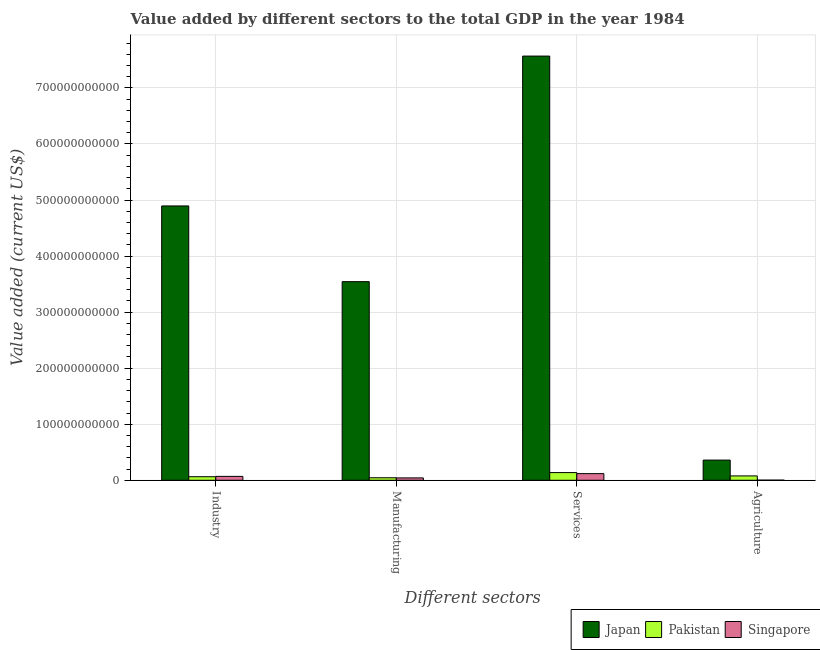Are the number of bars on each tick of the X-axis equal?
Your response must be concise. Yes. How many bars are there on the 1st tick from the right?
Make the answer very short. 3. What is the label of the 4th group of bars from the left?
Ensure brevity in your answer.  Agriculture. What is the value added by industrial sector in Pakistan?
Provide a short and direct response. 6.31e+09. Across all countries, what is the maximum value added by industrial sector?
Offer a very short reply. 4.89e+11. Across all countries, what is the minimum value added by industrial sector?
Ensure brevity in your answer.  6.31e+09. In which country was the value added by services sector minimum?
Provide a short and direct response. Singapore. What is the total value added by services sector in the graph?
Your answer should be very brief. 7.82e+11. What is the difference between the value added by services sector in Japan and that in Pakistan?
Provide a succinct answer. 7.43e+11. What is the difference between the value added by industrial sector in Pakistan and the value added by manufacturing sector in Japan?
Keep it short and to the point. -3.48e+11. What is the average value added by industrial sector per country?
Your response must be concise. 1.68e+11. What is the difference between the value added by manufacturing sector and value added by services sector in Japan?
Give a very brief answer. -4.02e+11. What is the ratio of the value added by agricultural sector in Singapore to that in Japan?
Make the answer very short. 0.01. Is the value added by manufacturing sector in Japan less than that in Singapore?
Your answer should be compact. No. What is the difference between the highest and the second highest value added by industrial sector?
Provide a succinct answer. 4.82e+11. What is the difference between the highest and the lowest value added by agricultural sector?
Offer a terse response. 3.58e+1. In how many countries, is the value added by manufacturing sector greater than the average value added by manufacturing sector taken over all countries?
Offer a very short reply. 1. Is it the case that in every country, the sum of the value added by services sector and value added by manufacturing sector is greater than the sum of value added by agricultural sector and value added by industrial sector?
Offer a terse response. No. What does the 3rd bar from the right in Industry represents?
Offer a terse response. Japan. Is it the case that in every country, the sum of the value added by industrial sector and value added by manufacturing sector is greater than the value added by services sector?
Keep it short and to the point. No. How many bars are there?
Your answer should be compact. 12. Are all the bars in the graph horizontal?
Offer a terse response. No. What is the difference between two consecutive major ticks on the Y-axis?
Ensure brevity in your answer.  1.00e+11. Does the graph contain grids?
Make the answer very short. Yes. How many legend labels are there?
Your response must be concise. 3. How are the legend labels stacked?
Your answer should be very brief. Horizontal. What is the title of the graph?
Your response must be concise. Value added by different sectors to the total GDP in the year 1984. Does "Lithuania" appear as one of the legend labels in the graph?
Your answer should be compact. No. What is the label or title of the X-axis?
Provide a succinct answer. Different sectors. What is the label or title of the Y-axis?
Provide a short and direct response. Value added (current US$). What is the Value added (current US$) of Japan in Industry?
Offer a very short reply. 4.89e+11. What is the Value added (current US$) of Pakistan in Industry?
Make the answer very short. 6.31e+09. What is the Value added (current US$) in Singapore in Industry?
Your answer should be compact. 6.94e+09. What is the Value added (current US$) in Japan in Manufacturing?
Keep it short and to the point. 3.54e+11. What is the Value added (current US$) in Pakistan in Manufacturing?
Make the answer very short. 4.48e+09. What is the Value added (current US$) of Singapore in Manufacturing?
Your response must be concise. 4.22e+09. What is the Value added (current US$) in Japan in Services?
Give a very brief answer. 7.57e+11. What is the Value added (current US$) in Pakistan in Services?
Your answer should be compact. 1.37e+1. What is the Value added (current US$) of Singapore in Services?
Make the answer very short. 1.18e+1. What is the Value added (current US$) of Japan in Agriculture?
Make the answer very short. 3.60e+1. What is the Value added (current US$) in Pakistan in Agriculture?
Give a very brief answer. 7.75e+09. What is the Value added (current US$) of Singapore in Agriculture?
Ensure brevity in your answer.  2.11e+08. Across all Different sectors, what is the maximum Value added (current US$) in Japan?
Provide a succinct answer. 7.57e+11. Across all Different sectors, what is the maximum Value added (current US$) in Pakistan?
Your answer should be compact. 1.37e+1. Across all Different sectors, what is the maximum Value added (current US$) of Singapore?
Your answer should be very brief. 1.18e+1. Across all Different sectors, what is the minimum Value added (current US$) in Japan?
Make the answer very short. 3.60e+1. Across all Different sectors, what is the minimum Value added (current US$) in Pakistan?
Ensure brevity in your answer.  4.48e+09. Across all Different sectors, what is the minimum Value added (current US$) of Singapore?
Keep it short and to the point. 2.11e+08. What is the total Value added (current US$) in Japan in the graph?
Make the answer very short. 1.64e+12. What is the total Value added (current US$) of Pakistan in the graph?
Make the answer very short. 3.23e+1. What is the total Value added (current US$) in Singapore in the graph?
Ensure brevity in your answer.  2.32e+1. What is the difference between the Value added (current US$) in Japan in Industry and that in Manufacturing?
Your answer should be very brief. 1.35e+11. What is the difference between the Value added (current US$) in Pakistan in Industry and that in Manufacturing?
Your answer should be very brief. 1.83e+09. What is the difference between the Value added (current US$) of Singapore in Industry and that in Manufacturing?
Your response must be concise. 2.72e+09. What is the difference between the Value added (current US$) of Japan in Industry and that in Services?
Make the answer very short. -2.67e+11. What is the difference between the Value added (current US$) in Pakistan in Industry and that in Services?
Give a very brief answer. -7.41e+09. What is the difference between the Value added (current US$) of Singapore in Industry and that in Services?
Your response must be concise. -4.90e+09. What is the difference between the Value added (current US$) in Japan in Industry and that in Agriculture?
Ensure brevity in your answer.  4.53e+11. What is the difference between the Value added (current US$) of Pakistan in Industry and that in Agriculture?
Provide a short and direct response. -1.45e+09. What is the difference between the Value added (current US$) of Singapore in Industry and that in Agriculture?
Provide a short and direct response. 6.73e+09. What is the difference between the Value added (current US$) in Japan in Manufacturing and that in Services?
Give a very brief answer. -4.02e+11. What is the difference between the Value added (current US$) in Pakistan in Manufacturing and that in Services?
Your response must be concise. -9.23e+09. What is the difference between the Value added (current US$) in Singapore in Manufacturing and that in Services?
Give a very brief answer. -7.62e+09. What is the difference between the Value added (current US$) of Japan in Manufacturing and that in Agriculture?
Make the answer very short. 3.18e+11. What is the difference between the Value added (current US$) of Pakistan in Manufacturing and that in Agriculture?
Your answer should be very brief. -3.27e+09. What is the difference between the Value added (current US$) in Singapore in Manufacturing and that in Agriculture?
Provide a succinct answer. 4.01e+09. What is the difference between the Value added (current US$) of Japan in Services and that in Agriculture?
Provide a short and direct response. 7.21e+11. What is the difference between the Value added (current US$) of Pakistan in Services and that in Agriculture?
Your answer should be compact. 5.96e+09. What is the difference between the Value added (current US$) of Singapore in Services and that in Agriculture?
Provide a short and direct response. 1.16e+1. What is the difference between the Value added (current US$) in Japan in Industry and the Value added (current US$) in Pakistan in Manufacturing?
Make the answer very short. 4.85e+11. What is the difference between the Value added (current US$) of Japan in Industry and the Value added (current US$) of Singapore in Manufacturing?
Your answer should be compact. 4.85e+11. What is the difference between the Value added (current US$) in Pakistan in Industry and the Value added (current US$) in Singapore in Manufacturing?
Your answer should be compact. 2.08e+09. What is the difference between the Value added (current US$) in Japan in Industry and the Value added (current US$) in Pakistan in Services?
Provide a succinct answer. 4.76e+11. What is the difference between the Value added (current US$) of Japan in Industry and the Value added (current US$) of Singapore in Services?
Keep it short and to the point. 4.78e+11. What is the difference between the Value added (current US$) of Pakistan in Industry and the Value added (current US$) of Singapore in Services?
Your answer should be very brief. -5.54e+09. What is the difference between the Value added (current US$) in Japan in Industry and the Value added (current US$) in Pakistan in Agriculture?
Provide a short and direct response. 4.82e+11. What is the difference between the Value added (current US$) of Japan in Industry and the Value added (current US$) of Singapore in Agriculture?
Make the answer very short. 4.89e+11. What is the difference between the Value added (current US$) in Pakistan in Industry and the Value added (current US$) in Singapore in Agriculture?
Ensure brevity in your answer.  6.10e+09. What is the difference between the Value added (current US$) in Japan in Manufacturing and the Value added (current US$) in Pakistan in Services?
Ensure brevity in your answer.  3.41e+11. What is the difference between the Value added (current US$) in Japan in Manufacturing and the Value added (current US$) in Singapore in Services?
Offer a terse response. 3.42e+11. What is the difference between the Value added (current US$) of Pakistan in Manufacturing and the Value added (current US$) of Singapore in Services?
Your answer should be very brief. -7.36e+09. What is the difference between the Value added (current US$) in Japan in Manufacturing and the Value added (current US$) in Pakistan in Agriculture?
Provide a succinct answer. 3.47e+11. What is the difference between the Value added (current US$) of Japan in Manufacturing and the Value added (current US$) of Singapore in Agriculture?
Ensure brevity in your answer.  3.54e+11. What is the difference between the Value added (current US$) in Pakistan in Manufacturing and the Value added (current US$) in Singapore in Agriculture?
Give a very brief answer. 4.27e+09. What is the difference between the Value added (current US$) of Japan in Services and the Value added (current US$) of Pakistan in Agriculture?
Provide a short and direct response. 7.49e+11. What is the difference between the Value added (current US$) in Japan in Services and the Value added (current US$) in Singapore in Agriculture?
Keep it short and to the point. 7.57e+11. What is the difference between the Value added (current US$) in Pakistan in Services and the Value added (current US$) in Singapore in Agriculture?
Offer a very short reply. 1.35e+1. What is the average Value added (current US$) in Japan per Different sectors?
Provide a short and direct response. 4.09e+11. What is the average Value added (current US$) of Pakistan per Different sectors?
Provide a short and direct response. 8.07e+09. What is the average Value added (current US$) in Singapore per Different sectors?
Your answer should be compact. 5.81e+09. What is the difference between the Value added (current US$) in Japan and Value added (current US$) in Pakistan in Industry?
Your answer should be compact. 4.83e+11. What is the difference between the Value added (current US$) of Japan and Value added (current US$) of Singapore in Industry?
Your answer should be very brief. 4.82e+11. What is the difference between the Value added (current US$) of Pakistan and Value added (current US$) of Singapore in Industry?
Your answer should be compact. -6.33e+08. What is the difference between the Value added (current US$) in Japan and Value added (current US$) in Pakistan in Manufacturing?
Provide a short and direct response. 3.50e+11. What is the difference between the Value added (current US$) of Japan and Value added (current US$) of Singapore in Manufacturing?
Your response must be concise. 3.50e+11. What is the difference between the Value added (current US$) in Pakistan and Value added (current US$) in Singapore in Manufacturing?
Your answer should be compact. 2.58e+08. What is the difference between the Value added (current US$) of Japan and Value added (current US$) of Pakistan in Services?
Your answer should be compact. 7.43e+11. What is the difference between the Value added (current US$) of Japan and Value added (current US$) of Singapore in Services?
Give a very brief answer. 7.45e+11. What is the difference between the Value added (current US$) in Pakistan and Value added (current US$) in Singapore in Services?
Keep it short and to the point. 1.87e+09. What is the difference between the Value added (current US$) in Japan and Value added (current US$) in Pakistan in Agriculture?
Ensure brevity in your answer.  2.82e+1. What is the difference between the Value added (current US$) of Japan and Value added (current US$) of Singapore in Agriculture?
Your answer should be compact. 3.58e+1. What is the difference between the Value added (current US$) in Pakistan and Value added (current US$) in Singapore in Agriculture?
Give a very brief answer. 7.54e+09. What is the ratio of the Value added (current US$) of Japan in Industry to that in Manufacturing?
Keep it short and to the point. 1.38. What is the ratio of the Value added (current US$) of Pakistan in Industry to that in Manufacturing?
Your answer should be very brief. 1.41. What is the ratio of the Value added (current US$) in Singapore in Industry to that in Manufacturing?
Offer a very short reply. 1.64. What is the ratio of the Value added (current US$) of Japan in Industry to that in Services?
Ensure brevity in your answer.  0.65. What is the ratio of the Value added (current US$) of Pakistan in Industry to that in Services?
Your answer should be very brief. 0.46. What is the ratio of the Value added (current US$) in Singapore in Industry to that in Services?
Provide a succinct answer. 0.59. What is the ratio of the Value added (current US$) in Japan in Industry to that in Agriculture?
Offer a terse response. 13.59. What is the ratio of the Value added (current US$) of Pakistan in Industry to that in Agriculture?
Your answer should be compact. 0.81. What is the ratio of the Value added (current US$) in Singapore in Industry to that in Agriculture?
Offer a very short reply. 32.85. What is the ratio of the Value added (current US$) of Japan in Manufacturing to that in Services?
Your answer should be very brief. 0.47. What is the ratio of the Value added (current US$) in Pakistan in Manufacturing to that in Services?
Keep it short and to the point. 0.33. What is the ratio of the Value added (current US$) in Singapore in Manufacturing to that in Services?
Your answer should be very brief. 0.36. What is the ratio of the Value added (current US$) of Japan in Manufacturing to that in Agriculture?
Your answer should be compact. 9.84. What is the ratio of the Value added (current US$) in Pakistan in Manufacturing to that in Agriculture?
Your answer should be compact. 0.58. What is the ratio of the Value added (current US$) in Singapore in Manufacturing to that in Agriculture?
Your response must be concise. 19.99. What is the ratio of the Value added (current US$) in Japan in Services to that in Agriculture?
Your response must be concise. 21.02. What is the ratio of the Value added (current US$) in Pakistan in Services to that in Agriculture?
Offer a very short reply. 1.77. What is the ratio of the Value added (current US$) of Singapore in Services to that in Agriculture?
Offer a terse response. 56.06. What is the difference between the highest and the second highest Value added (current US$) in Japan?
Ensure brevity in your answer.  2.67e+11. What is the difference between the highest and the second highest Value added (current US$) in Pakistan?
Provide a succinct answer. 5.96e+09. What is the difference between the highest and the second highest Value added (current US$) in Singapore?
Give a very brief answer. 4.90e+09. What is the difference between the highest and the lowest Value added (current US$) in Japan?
Give a very brief answer. 7.21e+11. What is the difference between the highest and the lowest Value added (current US$) in Pakistan?
Your answer should be very brief. 9.23e+09. What is the difference between the highest and the lowest Value added (current US$) of Singapore?
Ensure brevity in your answer.  1.16e+1. 